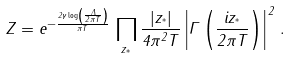Convert formula to latex. <formula><loc_0><loc_0><loc_500><loc_500>Z = e ^ { - \frac { 2 \gamma \log \left ( \frac { \Lambda } { 2 \pi T } \right ) } { \pi T } } \, \prod _ { z _ { ^ { * } } } \frac { | z _ { ^ { * } } | } { 4 \pi ^ { 2 } T } \left | \Gamma \left ( \frac { i z _ { ^ { * } } } { 2 \pi T } \right ) \right | ^ { 2 } \, .</formula> 